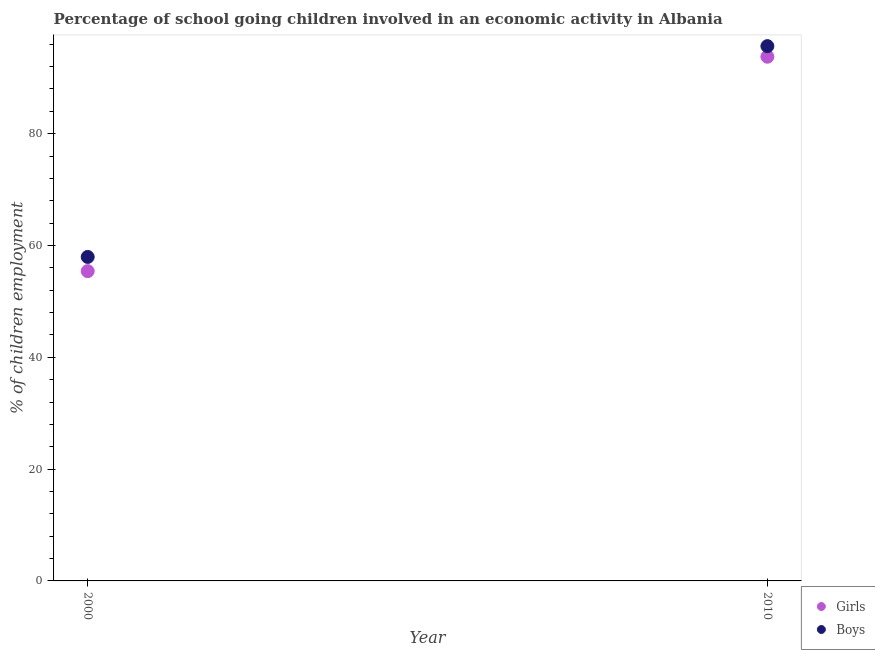How many different coloured dotlines are there?
Provide a succinct answer. 2. Is the number of dotlines equal to the number of legend labels?
Make the answer very short. Yes. What is the percentage of school going boys in 2000?
Make the answer very short. 57.95. Across all years, what is the maximum percentage of school going boys?
Offer a terse response. 95.65. Across all years, what is the minimum percentage of school going girls?
Provide a short and direct response. 55.41. In which year was the percentage of school going boys maximum?
Your response must be concise. 2010. In which year was the percentage of school going boys minimum?
Make the answer very short. 2000. What is the total percentage of school going girls in the graph?
Offer a very short reply. 149.17. What is the difference between the percentage of school going boys in 2000 and that in 2010?
Ensure brevity in your answer.  -37.7. What is the difference between the percentage of school going girls in 2010 and the percentage of school going boys in 2000?
Provide a short and direct response. 35.81. What is the average percentage of school going boys per year?
Provide a short and direct response. 76.8. In the year 2000, what is the difference between the percentage of school going girls and percentage of school going boys?
Offer a very short reply. -2.54. In how many years, is the percentage of school going boys greater than 92 %?
Provide a succinct answer. 1. What is the ratio of the percentage of school going girls in 2000 to that in 2010?
Your answer should be very brief. 0.59. Is the percentage of school going boys strictly greater than the percentage of school going girls over the years?
Your response must be concise. Yes. How many years are there in the graph?
Make the answer very short. 2. Where does the legend appear in the graph?
Give a very brief answer. Bottom right. How are the legend labels stacked?
Make the answer very short. Vertical. What is the title of the graph?
Offer a terse response. Percentage of school going children involved in an economic activity in Albania. What is the label or title of the Y-axis?
Your answer should be very brief. % of children employment. What is the % of children employment in Girls in 2000?
Your answer should be compact. 55.41. What is the % of children employment of Boys in 2000?
Keep it short and to the point. 57.95. What is the % of children employment of Girls in 2010?
Offer a very short reply. 93.76. What is the % of children employment in Boys in 2010?
Keep it short and to the point. 95.65. Across all years, what is the maximum % of children employment in Girls?
Keep it short and to the point. 93.76. Across all years, what is the maximum % of children employment in Boys?
Keep it short and to the point. 95.65. Across all years, what is the minimum % of children employment of Girls?
Your answer should be compact. 55.41. Across all years, what is the minimum % of children employment in Boys?
Your answer should be very brief. 57.95. What is the total % of children employment in Girls in the graph?
Keep it short and to the point. 149.17. What is the total % of children employment in Boys in the graph?
Ensure brevity in your answer.  153.6. What is the difference between the % of children employment of Girls in 2000 and that in 2010?
Ensure brevity in your answer.  -38.35. What is the difference between the % of children employment in Boys in 2000 and that in 2010?
Your answer should be compact. -37.7. What is the difference between the % of children employment of Girls in 2000 and the % of children employment of Boys in 2010?
Your answer should be compact. -40.24. What is the average % of children employment in Girls per year?
Your response must be concise. 74.58. What is the average % of children employment of Boys per year?
Your response must be concise. 76.8. In the year 2000, what is the difference between the % of children employment in Girls and % of children employment in Boys?
Offer a terse response. -2.54. In the year 2010, what is the difference between the % of children employment in Girls and % of children employment in Boys?
Your answer should be compact. -1.89. What is the ratio of the % of children employment of Girls in 2000 to that in 2010?
Your answer should be very brief. 0.59. What is the ratio of the % of children employment in Boys in 2000 to that in 2010?
Offer a very short reply. 0.61. What is the difference between the highest and the second highest % of children employment in Girls?
Offer a very short reply. 38.35. What is the difference between the highest and the second highest % of children employment in Boys?
Provide a short and direct response. 37.7. What is the difference between the highest and the lowest % of children employment of Girls?
Provide a short and direct response. 38.35. What is the difference between the highest and the lowest % of children employment of Boys?
Ensure brevity in your answer.  37.7. 